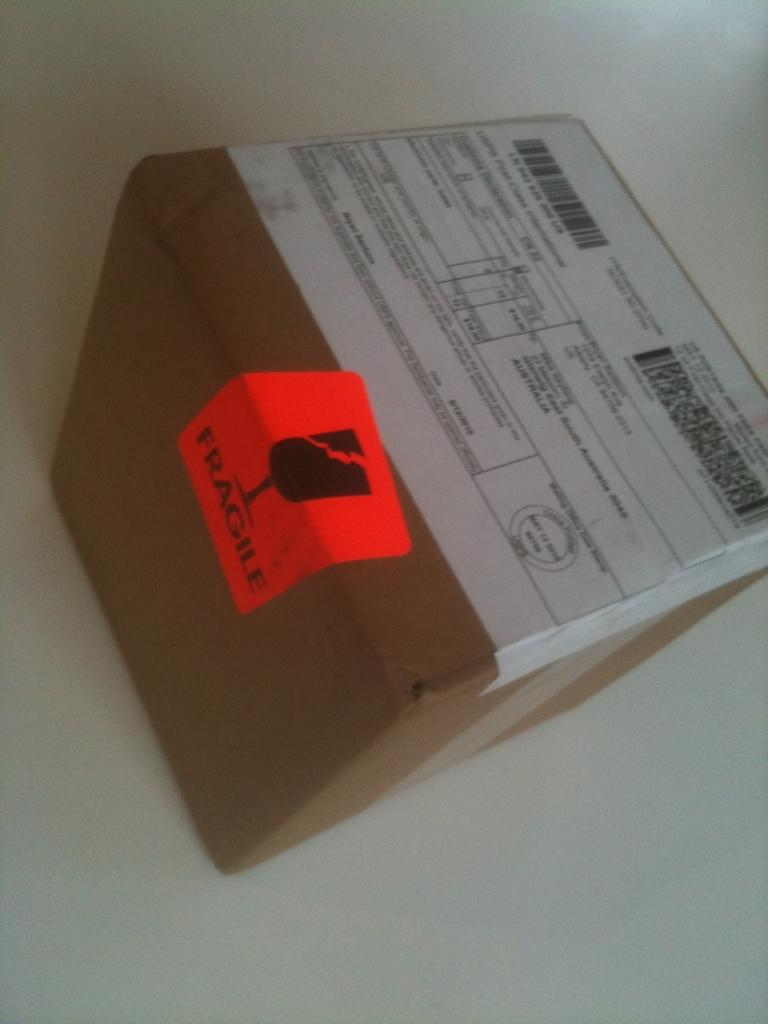<image>
Write a terse but informative summary of the picture. A box with a shipping label on top and fragile on the side 